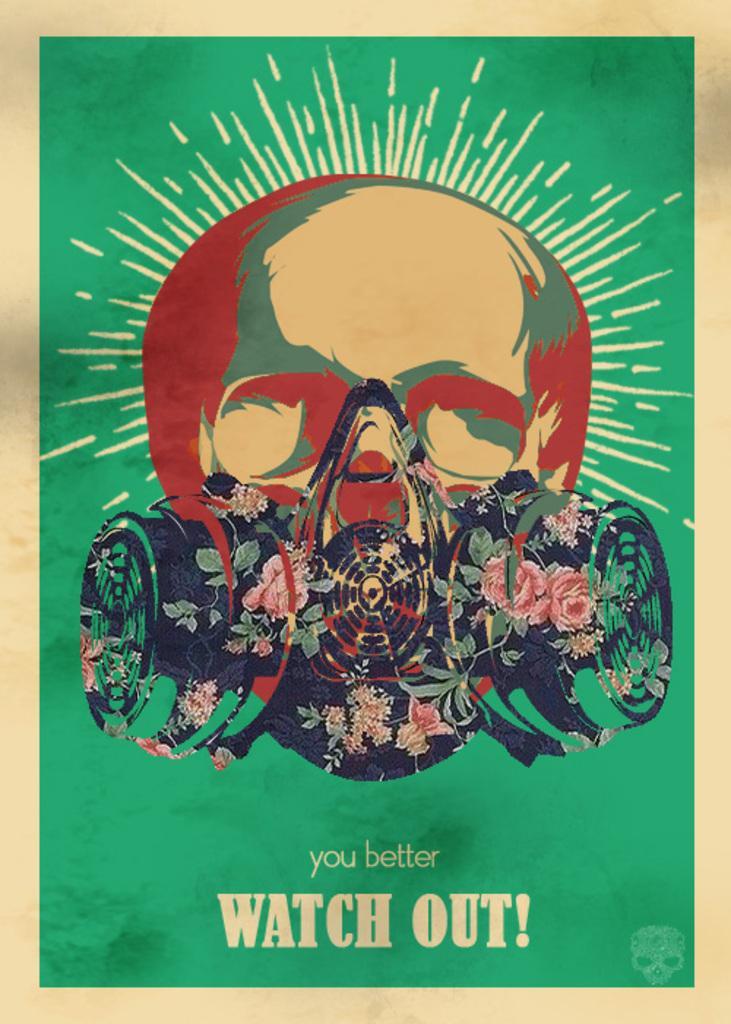Can you describe this image briefly? It is an edited image with some person's face with a mask. The background is in green color. There is a text and the image has borders. 